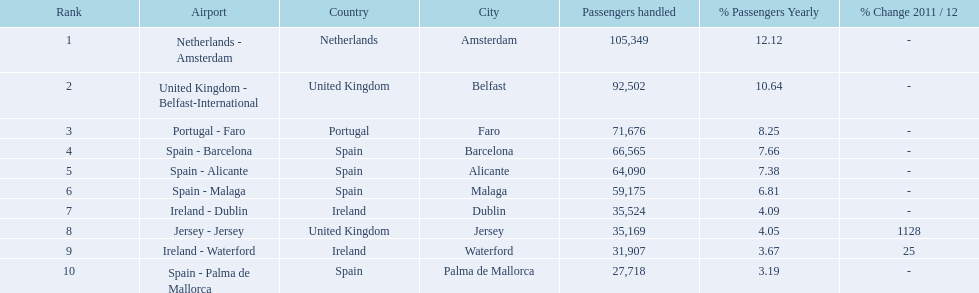How many passengers did the united kingdom handle? 92,502. Who handled more passengers than this? Netherlands - Amsterdam. 